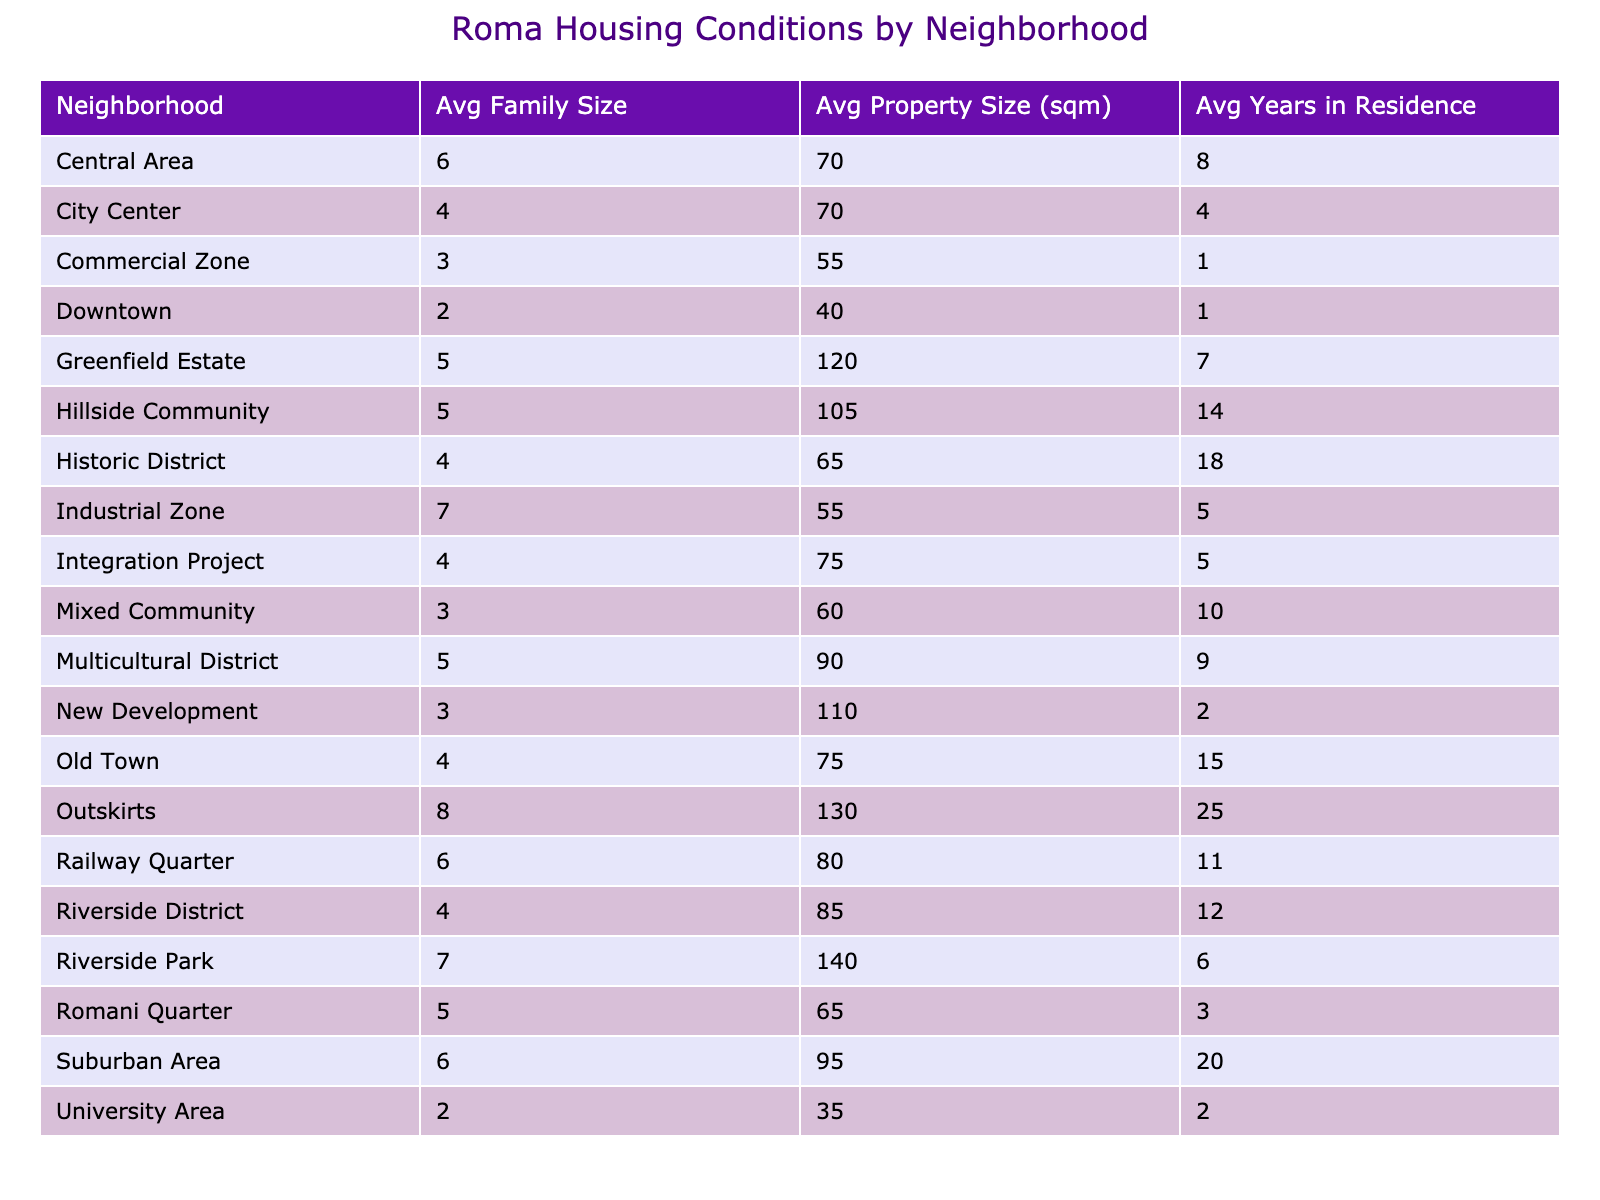What is the average property size in the Romani Quarter? The table shows the average property size in the Romani Quarter as 65 square meters, which means it's a direct lookup from the pivot data.
Answer: 65 sqm Which neighborhood has the highest average family size? By looking at the average family sizes listed in the table, Riverside Park has the highest average family size of 7 members.
Answer: 7 How many neighborhoods have an average property size greater than 90 square meters? We check the average property sizes in each neighborhood and find that Riverside Park, New Development, and Greenfield Estate have averages greater than 90 square meters. That gives us a total of 3 neighborhoods.
Answer: 3 Is there any neighborhood with an average family size less than 4? By examining the table, I see that both University Area and Downtown have average family sizes of 2 and 2, respectively, which confirms that there are neighborhoods with an average family size less than 4.
Answer: Yes What is the average property size of neighborhoods where the average family size is greater than 5? We list the neighborhoods with average family sizes greater than 5, which are Riverside Park, Old Town, and Nagy. Their corresponding property sizes are 140, 75, and 55 sqm. The average is calculated as (140 + 75 + 55) / 3 = 90 sqm.
Answer: 90 sqm In which neighborhood do families live the longest on average? The neighborhood with the longest average years in residence is the Outskirts, with 25 years, which I see directly under the years column in the table.
Answer: 25 years What is the average family size across the neighborhoods with owned properties? Looking at the data, the neighborhoods with 'Owned' status are Riverside District, Old Town, Suburban Area, Multicultural District, and Outskirts. Their average family sizes are 4, 4, 6, 5, and 8, respectively, leading to an average calculated as (4 + 4 + 6 + 5 + 8) / 5 = 5.4.
Answer: 5.4 How does the average family size in the Industrial Zone compare to the average in the Riverside District? The average family size in the Industrial Zone is 7, and in the Riverside District, it is 4. By comparing these two values, I find that families in the Industrial Zone are larger.
Answer: Industrial Zone has a larger average family size 